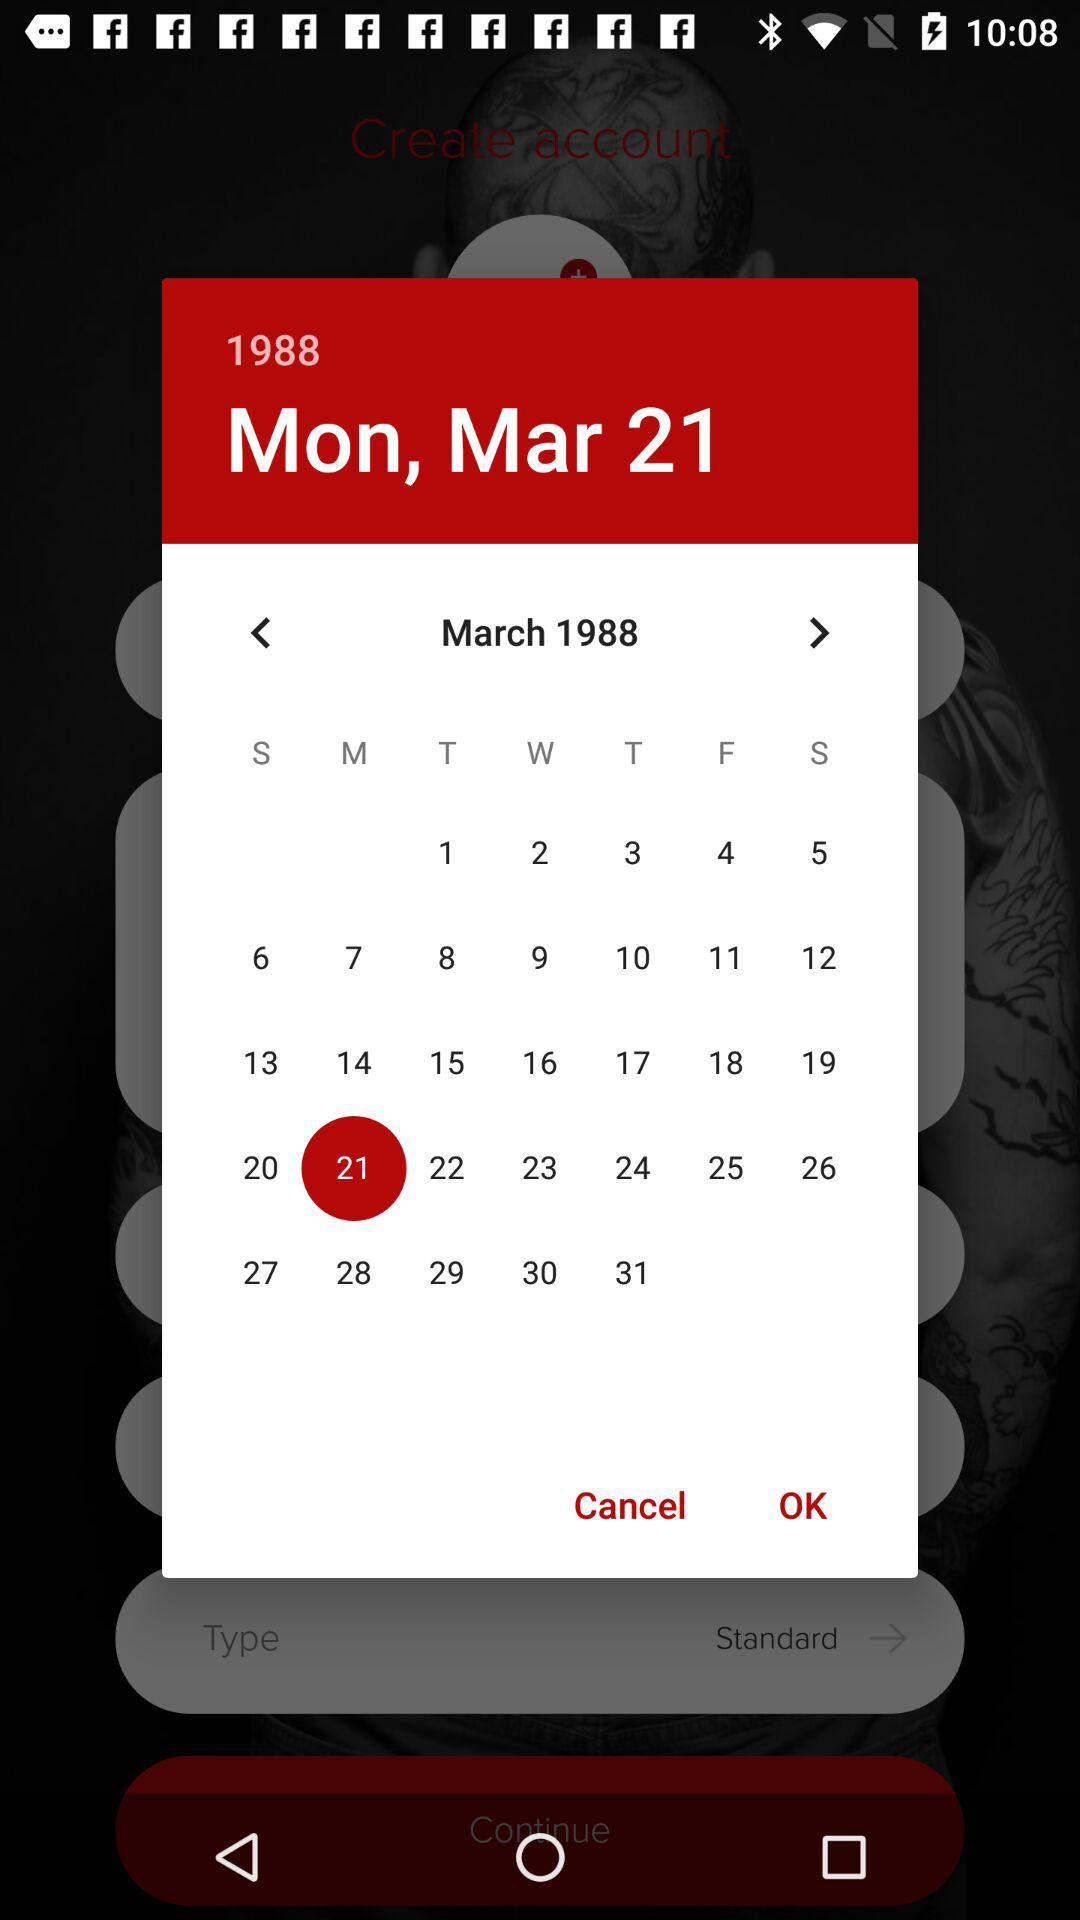What date is selected? The selected date is Monday, March 21, 1988. 